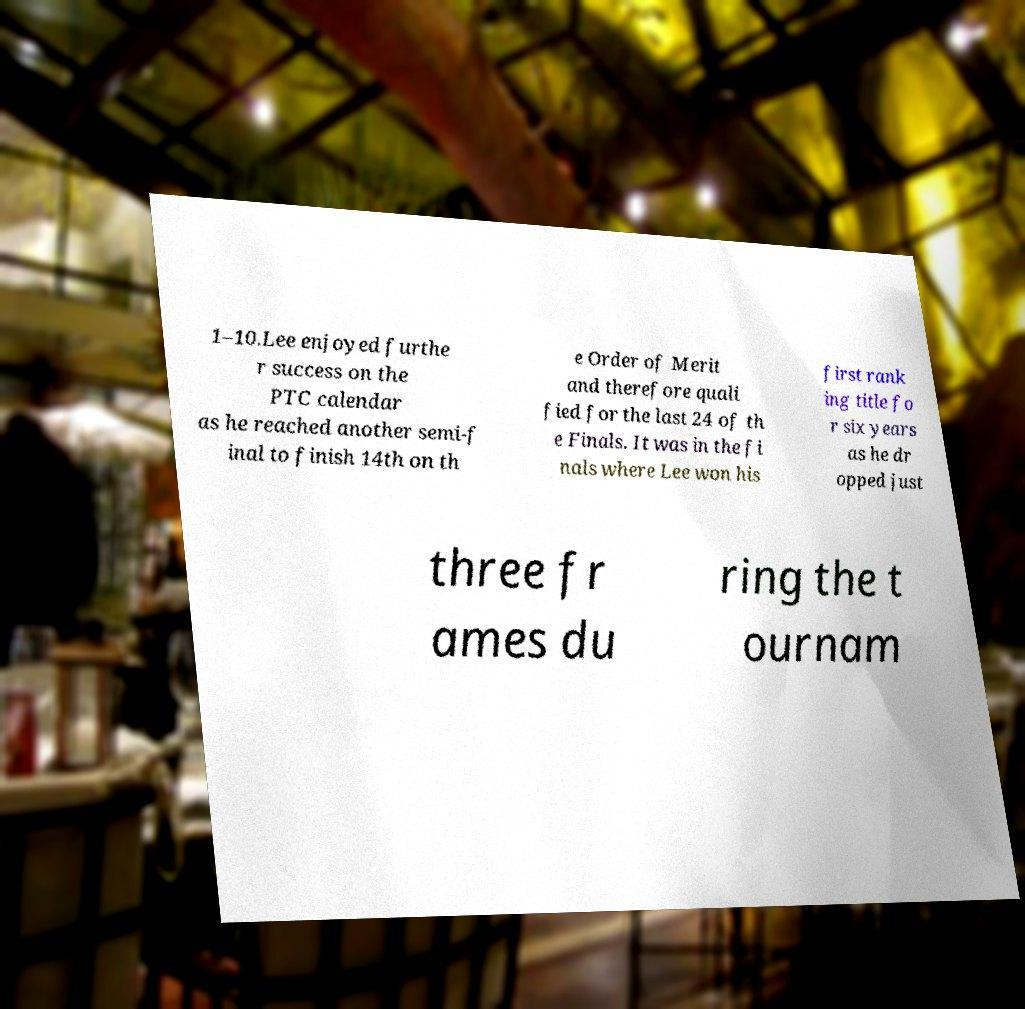Could you assist in decoding the text presented in this image and type it out clearly? 1–10.Lee enjoyed furthe r success on the PTC calendar as he reached another semi-f inal to finish 14th on th e Order of Merit and therefore quali fied for the last 24 of th e Finals. It was in the fi nals where Lee won his first rank ing title fo r six years as he dr opped just three fr ames du ring the t ournam 